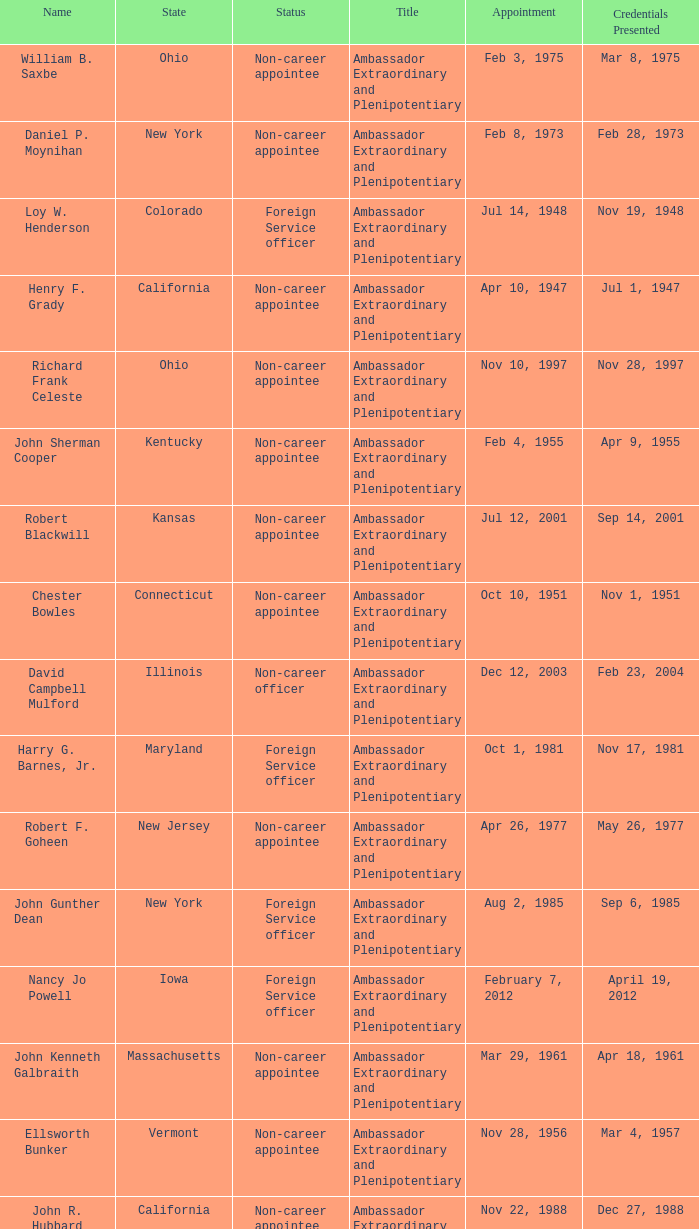Help me parse the entirety of this table. {'header': ['Name', 'State', 'Status', 'Title', 'Appointment', 'Credentials Presented'], 'rows': [['William B. Saxbe', 'Ohio', 'Non-career appointee', 'Ambassador Extraordinary and Plenipotentiary', 'Feb 3, 1975', 'Mar 8, 1975'], ['Daniel P. Moynihan', 'New York', 'Non-career appointee', 'Ambassador Extraordinary and Plenipotentiary', 'Feb 8, 1973', 'Feb 28, 1973'], ['Loy W. Henderson', 'Colorado', 'Foreign Service officer', 'Ambassador Extraordinary and Plenipotentiary', 'Jul 14, 1948', 'Nov 19, 1948'], ['Henry F. Grady', 'California', 'Non-career appointee', 'Ambassador Extraordinary and Plenipotentiary', 'Apr 10, 1947', 'Jul 1, 1947'], ['Richard Frank Celeste', 'Ohio', 'Non-career appointee', 'Ambassador Extraordinary and Plenipotentiary', 'Nov 10, 1997', 'Nov 28, 1997'], ['John Sherman Cooper', 'Kentucky', 'Non-career appointee', 'Ambassador Extraordinary and Plenipotentiary', 'Feb 4, 1955', 'Apr 9, 1955'], ['Robert Blackwill', 'Kansas', 'Non-career appointee', 'Ambassador Extraordinary and Plenipotentiary', 'Jul 12, 2001', 'Sep 14, 2001'], ['Chester Bowles', 'Connecticut', 'Non-career appointee', 'Ambassador Extraordinary and Plenipotentiary', 'Oct 10, 1951', 'Nov 1, 1951'], ['David Campbell Mulford', 'Illinois', 'Non-career officer', 'Ambassador Extraordinary and Plenipotentiary', 'Dec 12, 2003', 'Feb 23, 2004'], ['Harry G. Barnes, Jr.', 'Maryland', 'Foreign Service officer', 'Ambassador Extraordinary and Plenipotentiary', 'Oct 1, 1981', 'Nov 17, 1981'], ['Robert F. Goheen', 'New Jersey', 'Non-career appointee', 'Ambassador Extraordinary and Plenipotentiary', 'Apr 26, 1977', 'May 26, 1977'], ['John Gunther Dean', 'New York', 'Foreign Service officer', 'Ambassador Extraordinary and Plenipotentiary', 'Aug 2, 1985', 'Sep 6, 1985'], ['Nancy Jo Powell', 'Iowa', 'Foreign Service officer', 'Ambassador Extraordinary and Plenipotentiary', 'February 7, 2012', 'April 19, 2012'], ['John Kenneth Galbraith', 'Massachusetts', 'Non-career appointee', 'Ambassador Extraordinary and Plenipotentiary', 'Mar 29, 1961', 'Apr 18, 1961'], ['Ellsworth Bunker', 'Vermont', 'Non-career appointee', 'Ambassador Extraordinary and Plenipotentiary', 'Nov 28, 1956', 'Mar 4, 1957'], ['John R. Hubbard', 'California', 'Non-career appointee', 'Ambassador Extraordinary and Plenipotentiary', 'Nov 22, 1988', 'Dec 27, 1988'], ['William Clark, Jr.', 'District of Columbia', 'Foreign Service officer', 'Ambassador Extraordinary and Plenipotentiary', 'Oct 10, 1989', 'Dec 22, 1989'], ['Timothy J. Roemer', 'Indiana', 'Non-career appointee', 'Ambassador Extraordinary and Plenipotentiary', 'Jul 23, 2009', 'Aug 11, 2009'], ['Chester Bowles', 'Connecticut', 'Non-career appointee', 'Ambassador Extraordinary and Plenipotentiary', 'May 3, 1963', 'Jul 19, 1963'], ['Frank G. Wisner', 'District of Columbia', 'Foreign Service officer', 'Ambassador Extraordinary and Plenipotentiary', 'Jun 9, 1994', 'Aug 2, 1994'], ['Albert Peter Burleigh', 'California', 'Foreign Service officer', "Charge d'affaires", 'June 2011', 'Left post 2012'], ['George V. Allen', 'North Carolina', 'Foreign Service officer', 'Ambassador Extraordinary and Plenipotentiary', 'Mar 11, 1953', 'May 4, 1953'], ['Thomas R. Pickering', 'New Jersey', 'Foreign Service officer', 'Ambassador Extraordinary and Plenipotentiary', 'Apr 6, 1992', 'Aug 14, 1992'], ['Kenneth B. Keating', 'New York', 'Non-career appointee', 'Ambassador Extraordinary and Plenipotentiary', 'May 1, 1969', 'Jul 2, 1969']]} What state has an appointment for jul 12, 2001? Kansas. 